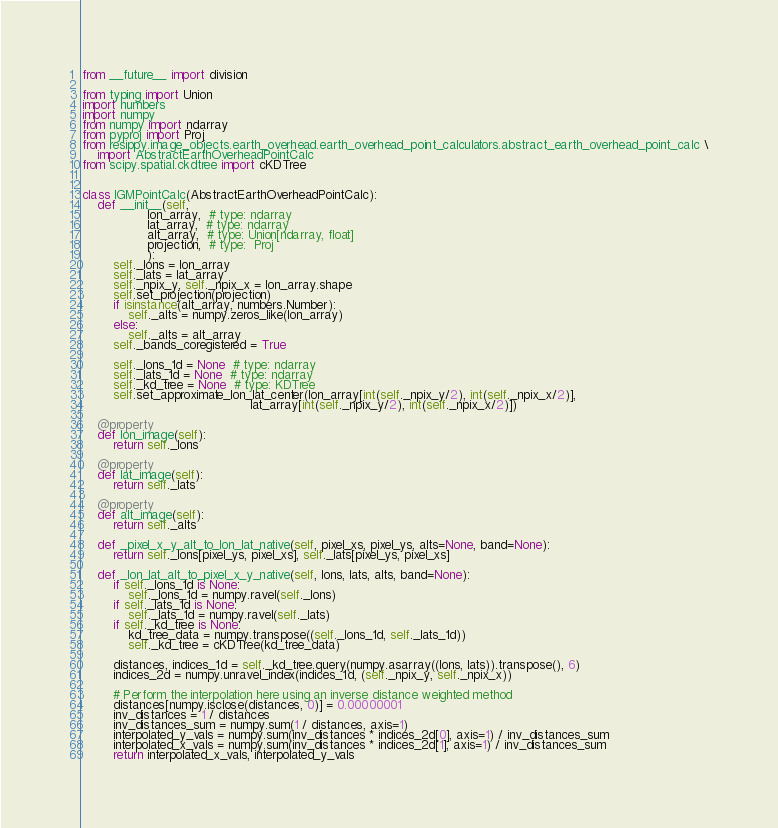<code> <loc_0><loc_0><loc_500><loc_500><_Python_>from __future__ import division

from typing import Union
import numbers
import numpy
from numpy import ndarray
from pyproj import Proj
from resippy.image_objects.earth_overhead.earth_overhead_point_calculators.abstract_earth_overhead_point_calc \
    import AbstractEarthOverheadPointCalc
from scipy.spatial.ckdtree import cKDTree


class IGMPointCalc(AbstractEarthOverheadPointCalc):
    def __init__(self,
                 lon_array,  # type: ndarray
                 lat_array,  # type: ndarray
                 alt_array,  # type: Union[ndarray, float]
                 projection,  # type:  Proj
                 ):
        self._lons = lon_array
        self._lats = lat_array
        self._npix_y, self._npix_x = lon_array.shape
        self.set_projection(projection)
        if isinstance(alt_array, numbers.Number):
            self._alts = numpy.zeros_like(lon_array)
        else:
            self._alts = alt_array
        self._bands_coregistered = True

        self._lons_1d = None  # type: ndarray
        self._lats_1d = None  # type: ndarray
        self._kd_tree = None  # type: KDTree
        self.set_approximate_lon_lat_center(lon_array[int(self._npix_y/2), int(self._npix_x/2)],
                                            lat_array[int(self._npix_y/2), int(self._npix_x/2)])

    @property
    def lon_image(self):
        return self._lons

    @property
    def lat_image(self):
        return self._lats

    @property
    def alt_image(self):
        return self._alts

    def _pixel_x_y_alt_to_lon_lat_native(self, pixel_xs, pixel_ys, alts=None, band=None):
        return self._lons[pixel_ys, pixel_xs], self._lats[pixel_ys, pixel_xs]

    def _lon_lat_alt_to_pixel_x_y_native(self, lons, lats, alts, band=None):
        if self._lons_1d is None:
            self._lons_1d = numpy.ravel(self._lons)
        if self._lats_1d is None:
            self._lats_1d = numpy.ravel(self._lats)
        if self._kd_tree is None:
            kd_tree_data = numpy.transpose((self._lons_1d, self._lats_1d))
            self._kd_tree = cKDTree(kd_tree_data)

        distances, indices_1d = self._kd_tree.query(numpy.asarray((lons, lats)).transpose(), 6)
        indices_2d = numpy.unravel_index(indices_1d, (self._npix_y, self._npix_x))

        # Perform the interpolation here using an inverse distance weighted method
        distances[numpy.isclose(distances, 0)] = 0.00000001
        inv_distances = 1 / distances
        inv_distances_sum = numpy.sum(1 / distances, axis=1)
        interpolated_y_vals = numpy.sum(inv_distances * indices_2d[0], axis=1) / inv_distances_sum
        interpolated_x_vals = numpy.sum(inv_distances * indices_2d[1], axis=1) / inv_distances_sum
        return interpolated_x_vals, interpolated_y_vals

</code> 